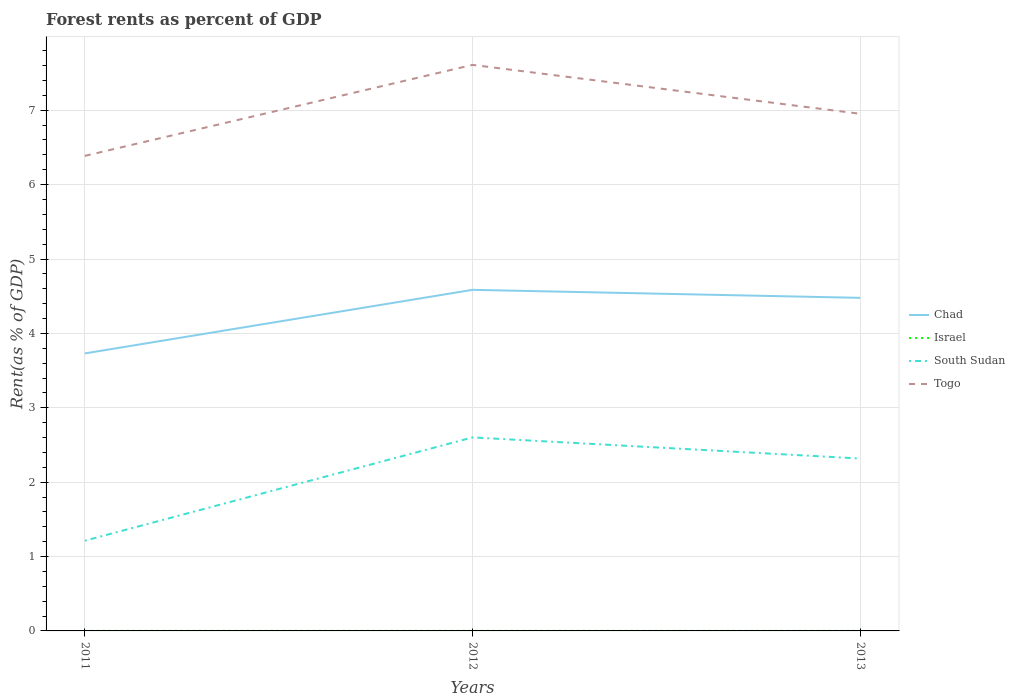Across all years, what is the maximum forest rent in South Sudan?
Your answer should be very brief. 1.21. What is the total forest rent in South Sudan in the graph?
Keep it short and to the point. 0.28. What is the difference between the highest and the second highest forest rent in Israel?
Provide a short and direct response. 0. How many lines are there?
Offer a terse response. 4. Does the graph contain any zero values?
Offer a terse response. No. Does the graph contain grids?
Your answer should be very brief. Yes. What is the title of the graph?
Make the answer very short. Forest rents as percent of GDP. What is the label or title of the Y-axis?
Your answer should be compact. Rent(as % of GDP). What is the Rent(as % of GDP) in Chad in 2011?
Keep it short and to the point. 3.73. What is the Rent(as % of GDP) in Israel in 2011?
Your response must be concise. 0. What is the Rent(as % of GDP) of South Sudan in 2011?
Make the answer very short. 1.21. What is the Rent(as % of GDP) in Togo in 2011?
Give a very brief answer. 6.39. What is the Rent(as % of GDP) of Chad in 2012?
Make the answer very short. 4.59. What is the Rent(as % of GDP) of Israel in 2012?
Your response must be concise. 0. What is the Rent(as % of GDP) in South Sudan in 2012?
Offer a very short reply. 2.6. What is the Rent(as % of GDP) of Togo in 2012?
Provide a succinct answer. 7.61. What is the Rent(as % of GDP) of Chad in 2013?
Provide a short and direct response. 4.48. What is the Rent(as % of GDP) in Israel in 2013?
Offer a terse response. 0. What is the Rent(as % of GDP) in South Sudan in 2013?
Keep it short and to the point. 2.32. What is the Rent(as % of GDP) of Togo in 2013?
Offer a terse response. 6.95. Across all years, what is the maximum Rent(as % of GDP) in Chad?
Your response must be concise. 4.59. Across all years, what is the maximum Rent(as % of GDP) in Israel?
Your answer should be compact. 0. Across all years, what is the maximum Rent(as % of GDP) of South Sudan?
Your response must be concise. 2.6. Across all years, what is the maximum Rent(as % of GDP) of Togo?
Give a very brief answer. 7.61. Across all years, what is the minimum Rent(as % of GDP) of Chad?
Keep it short and to the point. 3.73. Across all years, what is the minimum Rent(as % of GDP) in Israel?
Provide a short and direct response. 0. Across all years, what is the minimum Rent(as % of GDP) in South Sudan?
Ensure brevity in your answer.  1.21. Across all years, what is the minimum Rent(as % of GDP) of Togo?
Your response must be concise. 6.39. What is the total Rent(as % of GDP) of Chad in the graph?
Your response must be concise. 12.79. What is the total Rent(as % of GDP) of Israel in the graph?
Your answer should be compact. 0. What is the total Rent(as % of GDP) of South Sudan in the graph?
Make the answer very short. 6.13. What is the total Rent(as % of GDP) in Togo in the graph?
Offer a terse response. 20.95. What is the difference between the Rent(as % of GDP) in Chad in 2011 and that in 2012?
Provide a succinct answer. -0.85. What is the difference between the Rent(as % of GDP) of Israel in 2011 and that in 2012?
Your answer should be compact. 0. What is the difference between the Rent(as % of GDP) of South Sudan in 2011 and that in 2012?
Keep it short and to the point. -1.39. What is the difference between the Rent(as % of GDP) in Togo in 2011 and that in 2012?
Your answer should be compact. -1.22. What is the difference between the Rent(as % of GDP) in Chad in 2011 and that in 2013?
Offer a terse response. -0.75. What is the difference between the Rent(as % of GDP) of Israel in 2011 and that in 2013?
Give a very brief answer. 0. What is the difference between the Rent(as % of GDP) in South Sudan in 2011 and that in 2013?
Provide a succinct answer. -1.1. What is the difference between the Rent(as % of GDP) in Togo in 2011 and that in 2013?
Keep it short and to the point. -0.57. What is the difference between the Rent(as % of GDP) of Chad in 2012 and that in 2013?
Give a very brief answer. 0.11. What is the difference between the Rent(as % of GDP) in South Sudan in 2012 and that in 2013?
Give a very brief answer. 0.28. What is the difference between the Rent(as % of GDP) of Togo in 2012 and that in 2013?
Offer a terse response. 0.66. What is the difference between the Rent(as % of GDP) of Chad in 2011 and the Rent(as % of GDP) of Israel in 2012?
Make the answer very short. 3.73. What is the difference between the Rent(as % of GDP) of Chad in 2011 and the Rent(as % of GDP) of South Sudan in 2012?
Make the answer very short. 1.13. What is the difference between the Rent(as % of GDP) of Chad in 2011 and the Rent(as % of GDP) of Togo in 2012?
Provide a succinct answer. -3.88. What is the difference between the Rent(as % of GDP) in Israel in 2011 and the Rent(as % of GDP) in South Sudan in 2012?
Ensure brevity in your answer.  -2.6. What is the difference between the Rent(as % of GDP) in Israel in 2011 and the Rent(as % of GDP) in Togo in 2012?
Provide a succinct answer. -7.61. What is the difference between the Rent(as % of GDP) of South Sudan in 2011 and the Rent(as % of GDP) of Togo in 2012?
Keep it short and to the point. -6.4. What is the difference between the Rent(as % of GDP) of Chad in 2011 and the Rent(as % of GDP) of Israel in 2013?
Ensure brevity in your answer.  3.73. What is the difference between the Rent(as % of GDP) of Chad in 2011 and the Rent(as % of GDP) of South Sudan in 2013?
Provide a short and direct response. 1.41. What is the difference between the Rent(as % of GDP) of Chad in 2011 and the Rent(as % of GDP) of Togo in 2013?
Make the answer very short. -3.22. What is the difference between the Rent(as % of GDP) of Israel in 2011 and the Rent(as % of GDP) of South Sudan in 2013?
Your answer should be compact. -2.32. What is the difference between the Rent(as % of GDP) of Israel in 2011 and the Rent(as % of GDP) of Togo in 2013?
Keep it short and to the point. -6.95. What is the difference between the Rent(as % of GDP) in South Sudan in 2011 and the Rent(as % of GDP) in Togo in 2013?
Ensure brevity in your answer.  -5.74. What is the difference between the Rent(as % of GDP) of Chad in 2012 and the Rent(as % of GDP) of Israel in 2013?
Make the answer very short. 4.59. What is the difference between the Rent(as % of GDP) of Chad in 2012 and the Rent(as % of GDP) of South Sudan in 2013?
Your answer should be compact. 2.27. What is the difference between the Rent(as % of GDP) of Chad in 2012 and the Rent(as % of GDP) of Togo in 2013?
Your answer should be very brief. -2.37. What is the difference between the Rent(as % of GDP) of Israel in 2012 and the Rent(as % of GDP) of South Sudan in 2013?
Your answer should be very brief. -2.32. What is the difference between the Rent(as % of GDP) in Israel in 2012 and the Rent(as % of GDP) in Togo in 2013?
Provide a succinct answer. -6.95. What is the difference between the Rent(as % of GDP) of South Sudan in 2012 and the Rent(as % of GDP) of Togo in 2013?
Offer a very short reply. -4.35. What is the average Rent(as % of GDP) of Chad per year?
Ensure brevity in your answer.  4.26. What is the average Rent(as % of GDP) of Israel per year?
Your response must be concise. 0. What is the average Rent(as % of GDP) in South Sudan per year?
Your answer should be compact. 2.04. What is the average Rent(as % of GDP) in Togo per year?
Ensure brevity in your answer.  6.98. In the year 2011, what is the difference between the Rent(as % of GDP) of Chad and Rent(as % of GDP) of Israel?
Ensure brevity in your answer.  3.73. In the year 2011, what is the difference between the Rent(as % of GDP) of Chad and Rent(as % of GDP) of South Sudan?
Your answer should be very brief. 2.52. In the year 2011, what is the difference between the Rent(as % of GDP) of Chad and Rent(as % of GDP) of Togo?
Your answer should be very brief. -2.66. In the year 2011, what is the difference between the Rent(as % of GDP) in Israel and Rent(as % of GDP) in South Sudan?
Your answer should be compact. -1.21. In the year 2011, what is the difference between the Rent(as % of GDP) in Israel and Rent(as % of GDP) in Togo?
Ensure brevity in your answer.  -6.39. In the year 2011, what is the difference between the Rent(as % of GDP) of South Sudan and Rent(as % of GDP) of Togo?
Provide a succinct answer. -5.17. In the year 2012, what is the difference between the Rent(as % of GDP) of Chad and Rent(as % of GDP) of Israel?
Your answer should be compact. 4.58. In the year 2012, what is the difference between the Rent(as % of GDP) of Chad and Rent(as % of GDP) of South Sudan?
Offer a very short reply. 1.98. In the year 2012, what is the difference between the Rent(as % of GDP) of Chad and Rent(as % of GDP) of Togo?
Your answer should be very brief. -3.02. In the year 2012, what is the difference between the Rent(as % of GDP) in Israel and Rent(as % of GDP) in South Sudan?
Your answer should be very brief. -2.6. In the year 2012, what is the difference between the Rent(as % of GDP) in Israel and Rent(as % of GDP) in Togo?
Your answer should be very brief. -7.61. In the year 2012, what is the difference between the Rent(as % of GDP) in South Sudan and Rent(as % of GDP) in Togo?
Offer a terse response. -5.01. In the year 2013, what is the difference between the Rent(as % of GDP) in Chad and Rent(as % of GDP) in Israel?
Offer a very short reply. 4.48. In the year 2013, what is the difference between the Rent(as % of GDP) of Chad and Rent(as % of GDP) of South Sudan?
Your answer should be compact. 2.16. In the year 2013, what is the difference between the Rent(as % of GDP) of Chad and Rent(as % of GDP) of Togo?
Give a very brief answer. -2.47. In the year 2013, what is the difference between the Rent(as % of GDP) in Israel and Rent(as % of GDP) in South Sudan?
Ensure brevity in your answer.  -2.32. In the year 2013, what is the difference between the Rent(as % of GDP) of Israel and Rent(as % of GDP) of Togo?
Ensure brevity in your answer.  -6.95. In the year 2013, what is the difference between the Rent(as % of GDP) in South Sudan and Rent(as % of GDP) in Togo?
Your response must be concise. -4.63. What is the ratio of the Rent(as % of GDP) of Chad in 2011 to that in 2012?
Offer a very short reply. 0.81. What is the ratio of the Rent(as % of GDP) of Israel in 2011 to that in 2012?
Provide a short and direct response. 1.13. What is the ratio of the Rent(as % of GDP) of South Sudan in 2011 to that in 2012?
Keep it short and to the point. 0.47. What is the ratio of the Rent(as % of GDP) in Togo in 2011 to that in 2012?
Offer a very short reply. 0.84. What is the ratio of the Rent(as % of GDP) in Chad in 2011 to that in 2013?
Your response must be concise. 0.83. What is the ratio of the Rent(as % of GDP) in Israel in 2011 to that in 2013?
Offer a very short reply. 1.22. What is the ratio of the Rent(as % of GDP) in South Sudan in 2011 to that in 2013?
Offer a terse response. 0.52. What is the ratio of the Rent(as % of GDP) of Togo in 2011 to that in 2013?
Provide a short and direct response. 0.92. What is the ratio of the Rent(as % of GDP) of Israel in 2012 to that in 2013?
Your answer should be compact. 1.07. What is the ratio of the Rent(as % of GDP) in South Sudan in 2012 to that in 2013?
Ensure brevity in your answer.  1.12. What is the ratio of the Rent(as % of GDP) of Togo in 2012 to that in 2013?
Offer a very short reply. 1.09. What is the difference between the highest and the second highest Rent(as % of GDP) of Chad?
Your answer should be compact. 0.11. What is the difference between the highest and the second highest Rent(as % of GDP) in Israel?
Provide a succinct answer. 0. What is the difference between the highest and the second highest Rent(as % of GDP) of South Sudan?
Offer a very short reply. 0.28. What is the difference between the highest and the second highest Rent(as % of GDP) in Togo?
Keep it short and to the point. 0.66. What is the difference between the highest and the lowest Rent(as % of GDP) of Chad?
Keep it short and to the point. 0.85. What is the difference between the highest and the lowest Rent(as % of GDP) of Israel?
Provide a succinct answer. 0. What is the difference between the highest and the lowest Rent(as % of GDP) in South Sudan?
Your answer should be compact. 1.39. What is the difference between the highest and the lowest Rent(as % of GDP) in Togo?
Ensure brevity in your answer.  1.22. 